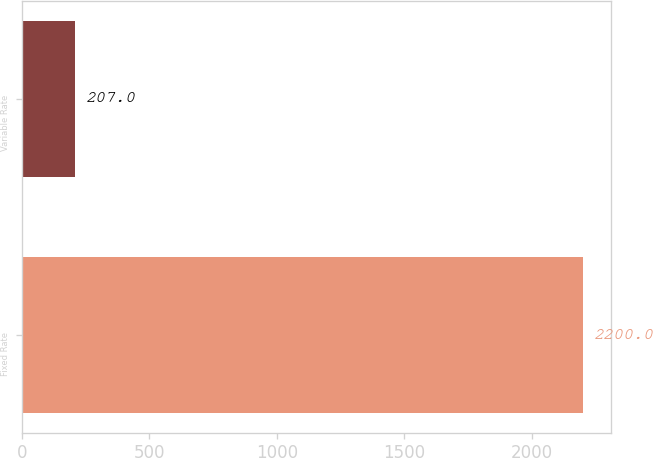<chart> <loc_0><loc_0><loc_500><loc_500><bar_chart><fcel>Fixed Rate<fcel>Variable Rate<nl><fcel>2200<fcel>207<nl></chart> 